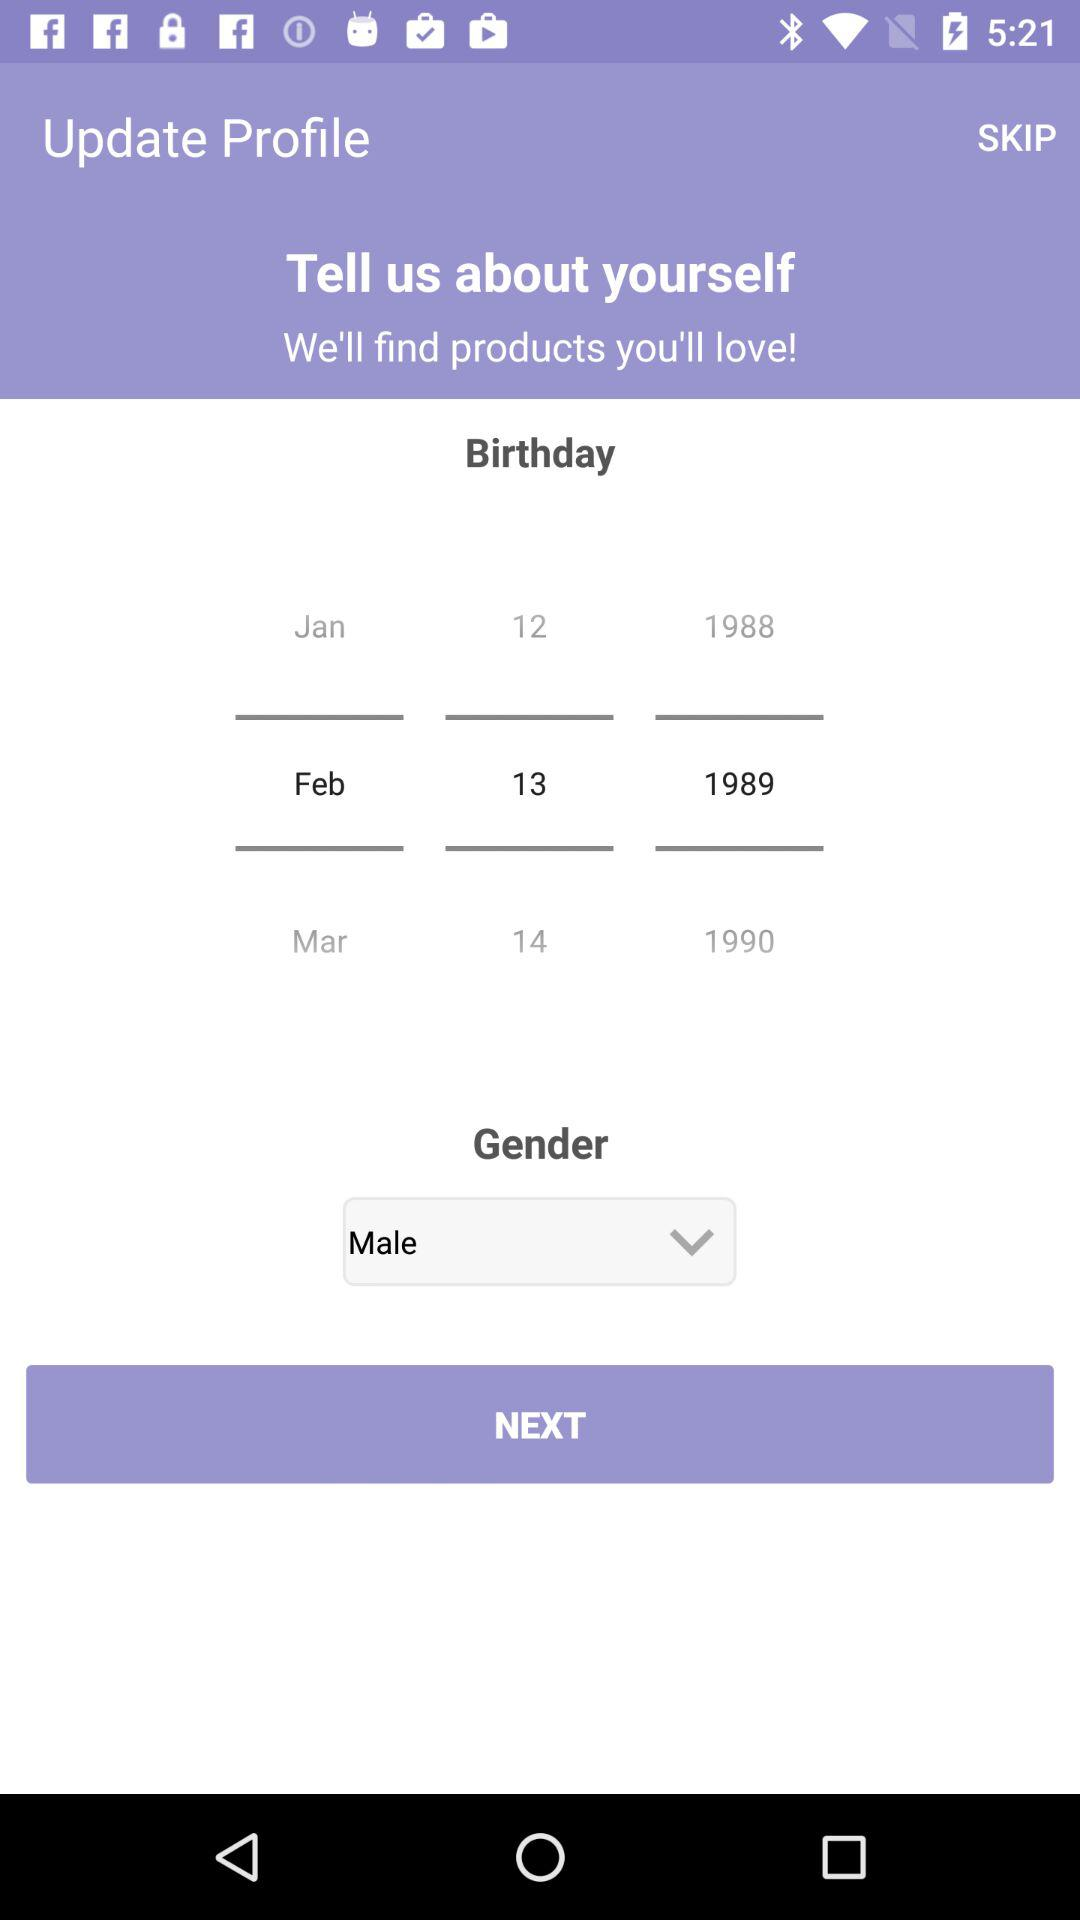What is the gender of the user? The gender of the user is male. 